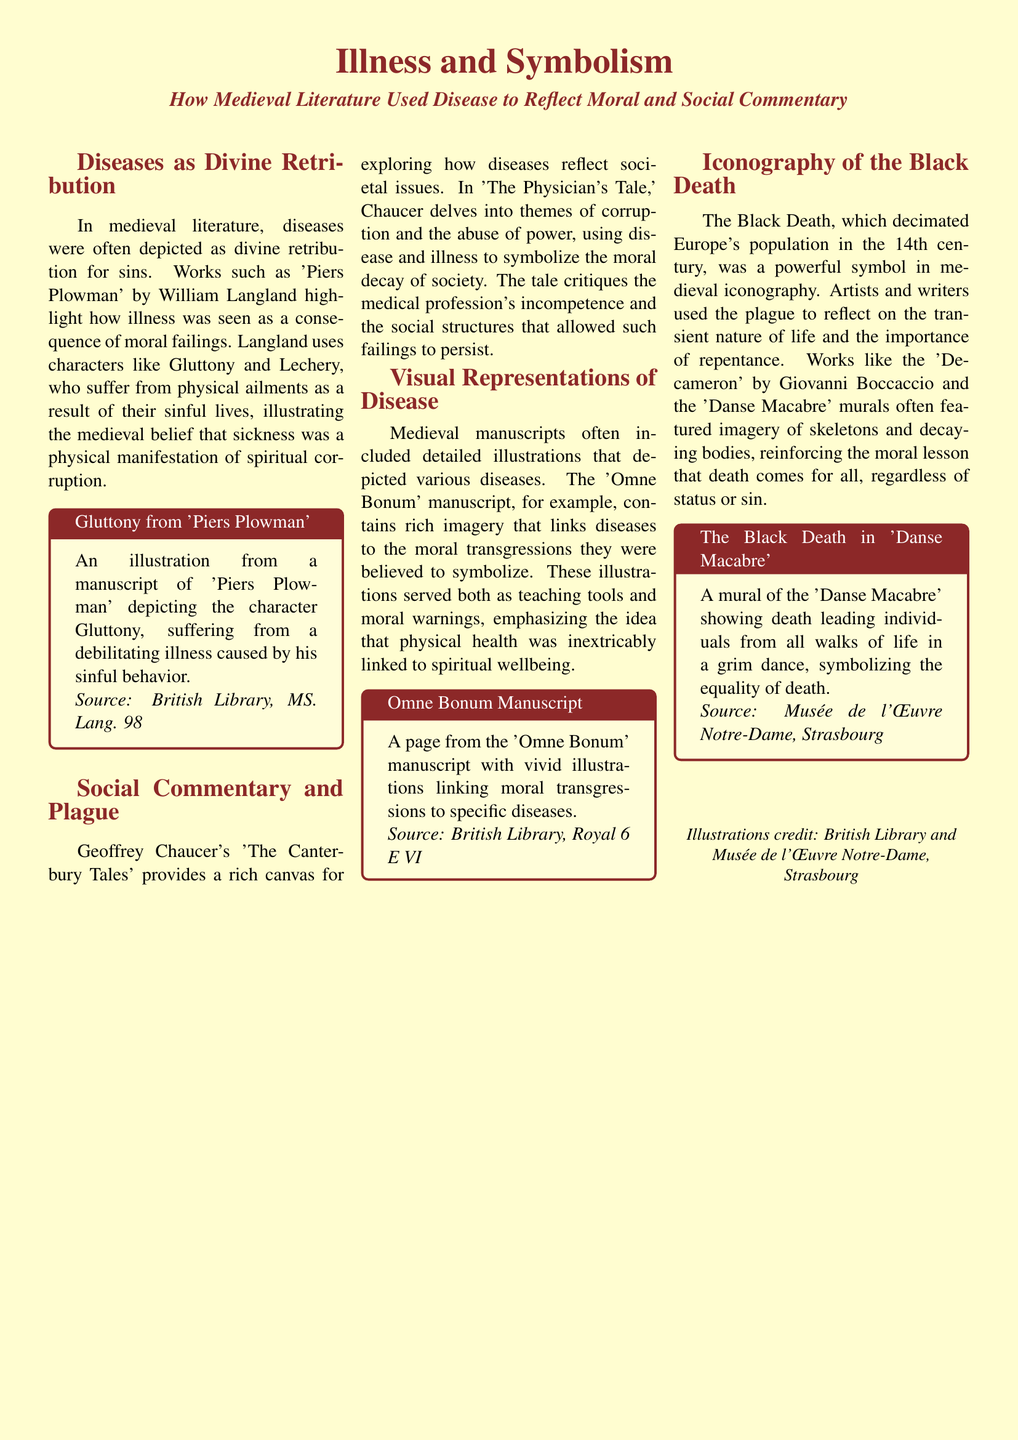What is the title of the article? The title of the article is presented prominently at the top of the document, indicating its focus.
Answer: Illness and Symbolism Who wrote 'Piers Plowman'? The author of 'Piers Plowman' is mentioned in the context of discussing disease and divine retribution in medieval literature.
Answer: William Langland What moral lesson does 'Danse Macabre' convey? The document explains that 'Danse Macabre' uses imagery to reflect the moral lesson regarding death's equality for all.
Answer: Equality of death Which manuscript depicts Gluttony suffering from illness? The document refers to a specific manuscript where Gluttony is illustrated suffering due to sinful behavior.
Answer: Piers Plowman What theme does Chaucer explore in 'The Physician's Tale'? The document indicates that Chaucer explores societal corruption through his storytelling in this particular tale.
Answer: Corruption What visual elements are linked to moral transgressions? The document mentions that certain images in the 'Omne Bonum' manuscript link specific diseases to moral failures.
Answer: Illustrations What does the Black Death symbolize in medieval literature? The document describes the Black Death as a powerful symbol reflecting transient life and a call for repentance.
Answer: Transience of life Which publication features the illustrations cited in this article? The document credits specific libraries as sources for the illustrations mentioned.
Answer: British Library How many sections are in the document's layout? The document is organized into sections that cover different themes related to illness and literature.
Answer: Four 